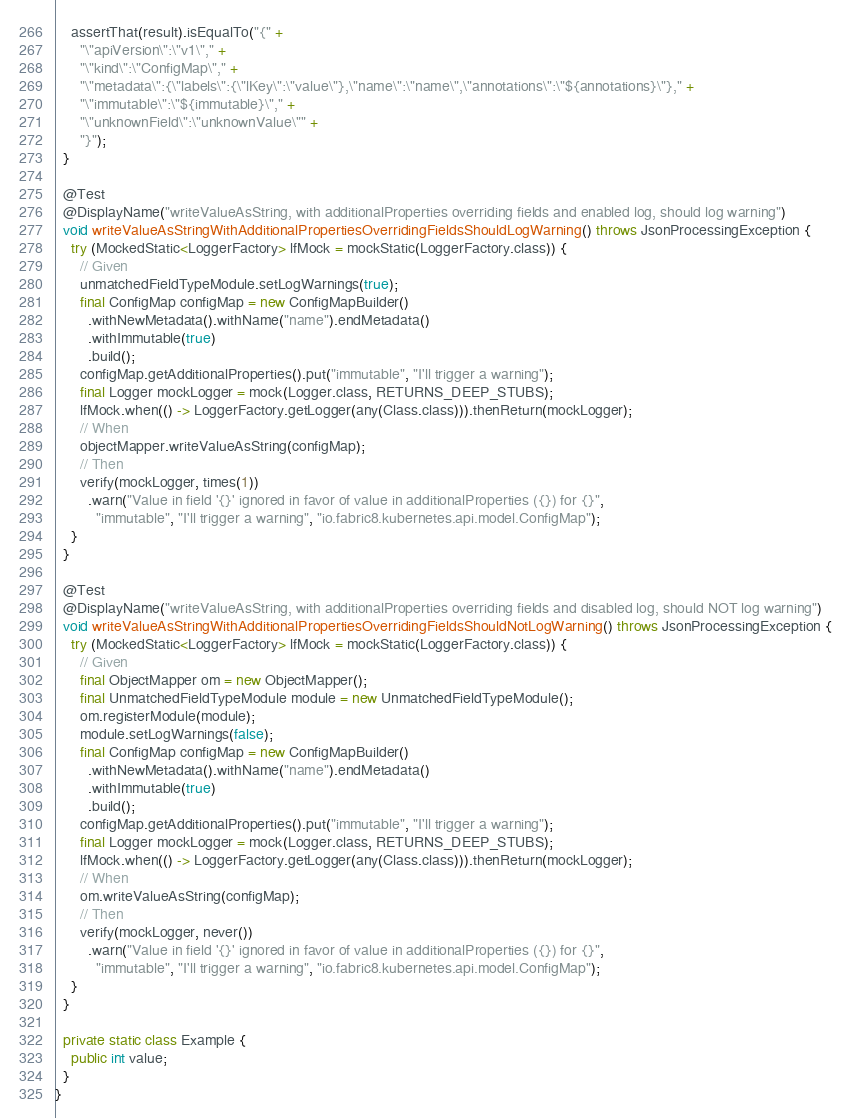Convert code to text. <code><loc_0><loc_0><loc_500><loc_500><_Java_>    assertThat(result).isEqualTo("{" +
      "\"apiVersion\":\"v1\"," +
      "\"kind\":\"ConfigMap\"," +
      "\"metadata\":{\"labels\":{\"lKey\":\"value\"},\"name\":\"name\",\"annotations\":\"${annotations}\"}," +
      "\"immutable\":\"${immutable}\"," +
      "\"unknownField\":\"unknownValue\"" +
      "}");
  }

  @Test
  @DisplayName("writeValueAsString, with additionalProperties overriding fields and enabled log, should log warning")
  void writeValueAsStringWithAdditionalPropertiesOverridingFieldsShouldLogWarning() throws JsonProcessingException {
    try (MockedStatic<LoggerFactory> lfMock = mockStatic(LoggerFactory.class)) {
      // Given
      unmatchedFieldTypeModule.setLogWarnings(true);
      final ConfigMap configMap = new ConfigMapBuilder()
        .withNewMetadata().withName("name").endMetadata()
        .withImmutable(true)
        .build();
      configMap.getAdditionalProperties().put("immutable", "I'll trigger a warning");
      final Logger mockLogger = mock(Logger.class, RETURNS_DEEP_STUBS);
      lfMock.when(() -> LoggerFactory.getLogger(any(Class.class))).thenReturn(mockLogger);
      // When
      objectMapper.writeValueAsString(configMap);
      // Then
      verify(mockLogger, times(1))
        .warn("Value in field '{}' ignored in favor of value in additionalProperties ({}) for {}",
          "immutable", "I'll trigger a warning", "io.fabric8.kubernetes.api.model.ConfigMap");
    }
  }

  @Test
  @DisplayName("writeValueAsString, with additionalProperties overriding fields and disabled log, should NOT log warning")
  void writeValueAsStringWithAdditionalPropertiesOverridingFieldsShouldNotLogWarning() throws JsonProcessingException {
    try (MockedStatic<LoggerFactory> lfMock = mockStatic(LoggerFactory.class)) {
      // Given
      final ObjectMapper om = new ObjectMapper();
      final UnmatchedFieldTypeModule module = new UnmatchedFieldTypeModule();
      om.registerModule(module);
      module.setLogWarnings(false);
      final ConfigMap configMap = new ConfigMapBuilder()
        .withNewMetadata().withName("name").endMetadata()
        .withImmutable(true)
        .build();
      configMap.getAdditionalProperties().put("immutable", "I'll trigger a warning");
      final Logger mockLogger = mock(Logger.class, RETURNS_DEEP_STUBS);
      lfMock.when(() -> LoggerFactory.getLogger(any(Class.class))).thenReturn(mockLogger);
      // When
      om.writeValueAsString(configMap);
      // Then
      verify(mockLogger, never())
        .warn("Value in field '{}' ignored in favor of value in additionalProperties ({}) for {}",
          "immutable", "I'll trigger a warning", "io.fabric8.kubernetes.api.model.ConfigMap");
    }
  }

  private static class Example {
    public int value;
  }
}
</code> 